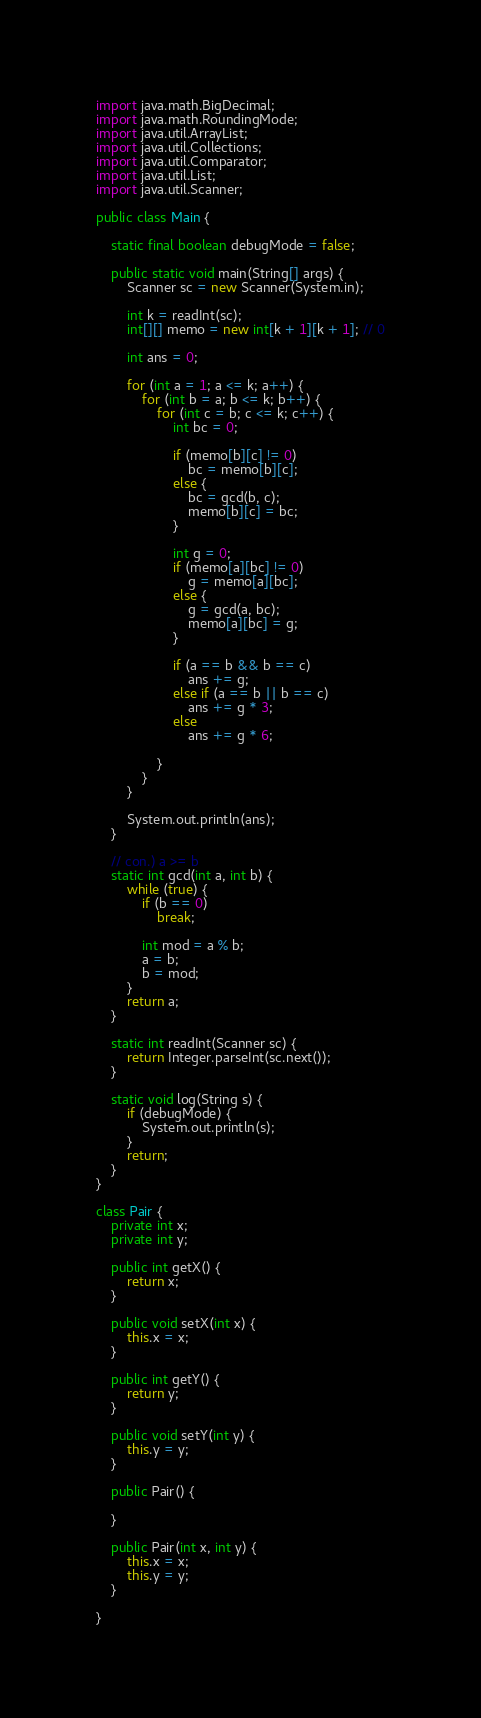Convert code to text. <code><loc_0><loc_0><loc_500><loc_500><_Java_>import java.math.BigDecimal;
import java.math.RoundingMode;
import java.util.ArrayList;
import java.util.Collections;
import java.util.Comparator;
import java.util.List;
import java.util.Scanner;

public class Main {

	static final boolean debugMode = false;

	public static void main(String[] args) {
		Scanner sc = new Scanner(System.in);

		int k = readInt(sc);
		int[][] memo = new int[k + 1][k + 1]; // 0

		int ans = 0;

		for (int a = 1; a <= k; a++) {
			for (int b = a; b <= k; b++) {
				for (int c = b; c <= k; c++) {
					int bc = 0;

					if (memo[b][c] != 0)
						bc = memo[b][c];
					else {
						bc = gcd(b, c);
						memo[b][c] = bc;
					}

					int g = 0;
					if (memo[a][bc] != 0)
						g = memo[a][bc];
					else {
						g = gcd(a, bc);
						memo[a][bc] = g;
					}

					if (a == b && b == c)
						ans += g;
					else if (a == b || b == c)
						ans += g * 3;
					else
						ans += g * 6;

				}
			}
		}

		System.out.println(ans);
	}

	// con.) a >= b
	static int gcd(int a, int b) {
		while (true) {
			if (b == 0)
				break;

			int mod = a % b;
			a = b;
			b = mod;
		}
		return a;
	}

	static int readInt(Scanner sc) {
		return Integer.parseInt(sc.next());
	}

	static void log(String s) {
		if (debugMode) {
			System.out.println(s);
		}
		return;
	}
}

class Pair {
	private int x;
	private int y;

	public int getX() {
		return x;
	}

	public void setX(int x) {
		this.x = x;
	}

	public int getY() {
		return y;
	}

	public void setY(int y) {
		this.y = y;
	}

	public Pair() {

	}

	public Pair(int x, int y) {
		this.x = x;
		this.y = y;
	}

}</code> 